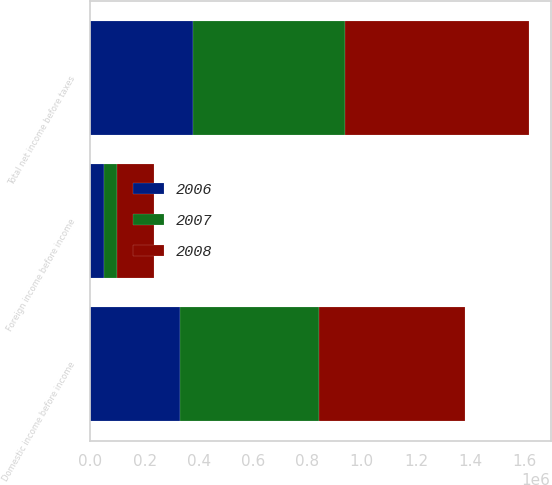<chart> <loc_0><loc_0><loc_500><loc_500><stacked_bar_chart><ecel><fcel>Domestic income before income<fcel>Foreign income before income<fcel>Total net income before taxes<nl><fcel>2007<fcel>511710<fcel>48523<fcel>560233<nl><fcel>2008<fcel>538257<fcel>138978<fcel>677235<nl><fcel>2006<fcel>329066<fcel>48792<fcel>377858<nl></chart> 